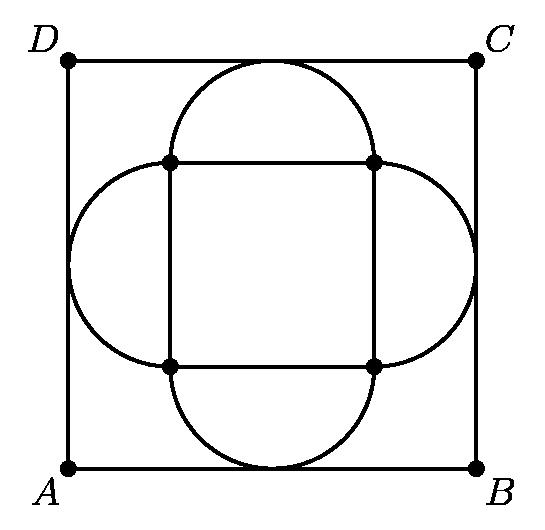How do we calculate the side length of the inner square $ABCD$? To calculate the side length of the inner square $ABCD$, we need to use the radius of the semicircles which is half the side of the outer square. Let's denote the side length of the outer square as $s$. The radius of the semicircles is thus $s/2$. The side length of $ABCD$ can be expressed in terms of $s$ and the radius of the semicircles, and using geometrical properties, we can then find an expression for the area of $ABCD$ in terms of $s$.  Could you elaborate on the relationship between the side length of $ABCD$ and the radius of the semicircles? Certainly, if we focus on one of the corners of the larger square, we will see that the distance from the tangent point on one side of the inner square $ABCD$ to the corner of the larger square is the radius of the semicircle. The same is true for the perpendicular distance on the adjacent side. If the side length of the larger square is $s$, then $ABCD$ will be a square with four equal sides of length $s - 2*(s/2)^2$ due to the Pythagorean theorem. Simplifying this, we find the side length of $ABCD$ is $s * (√2 - 1)$. Squaring this gives us the area of $ABCD$. 